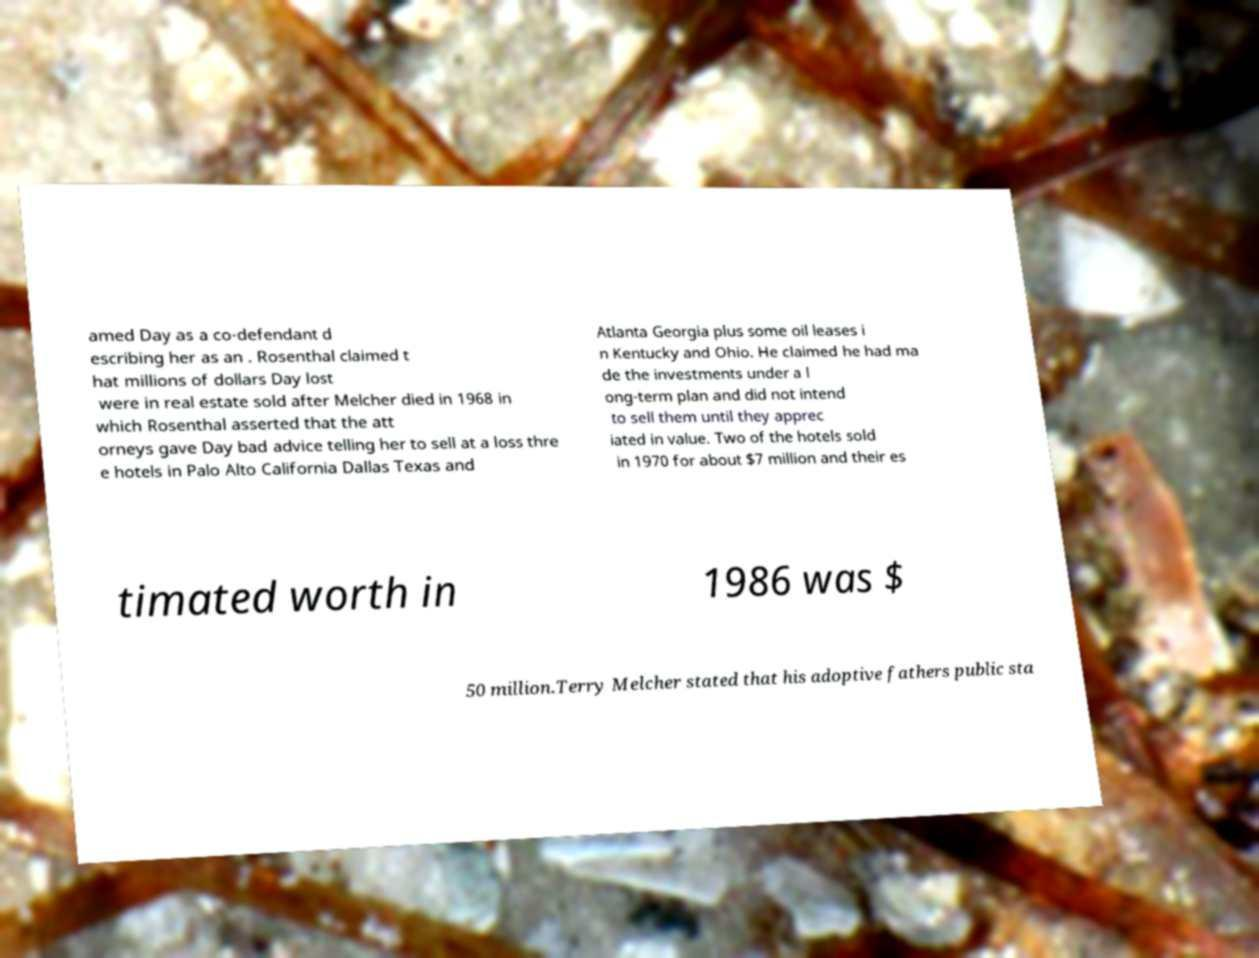Please read and relay the text visible in this image. What does it say? amed Day as a co-defendant d escribing her as an . Rosenthal claimed t hat millions of dollars Day lost were in real estate sold after Melcher died in 1968 in which Rosenthal asserted that the att orneys gave Day bad advice telling her to sell at a loss thre e hotels in Palo Alto California Dallas Texas and Atlanta Georgia plus some oil leases i n Kentucky and Ohio. He claimed he had ma de the investments under a l ong-term plan and did not intend to sell them until they apprec iated in value. Two of the hotels sold in 1970 for about $7 million and their es timated worth in 1986 was $ 50 million.Terry Melcher stated that his adoptive fathers public sta 